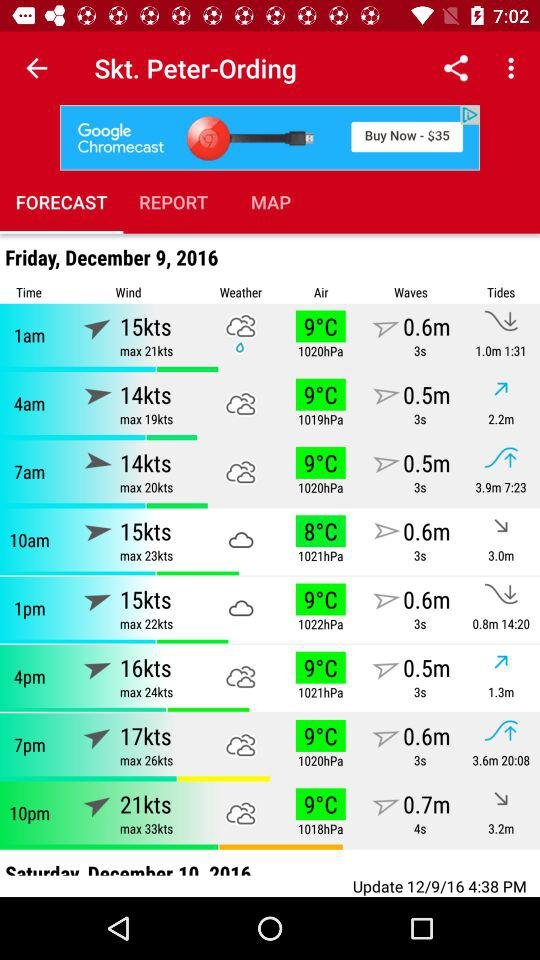How's the weather forecast for Friday, December 9, 2016 at 1 a.m.? The weather for Friday, December 9, 2016 at 1 a.m. is drizzle. 